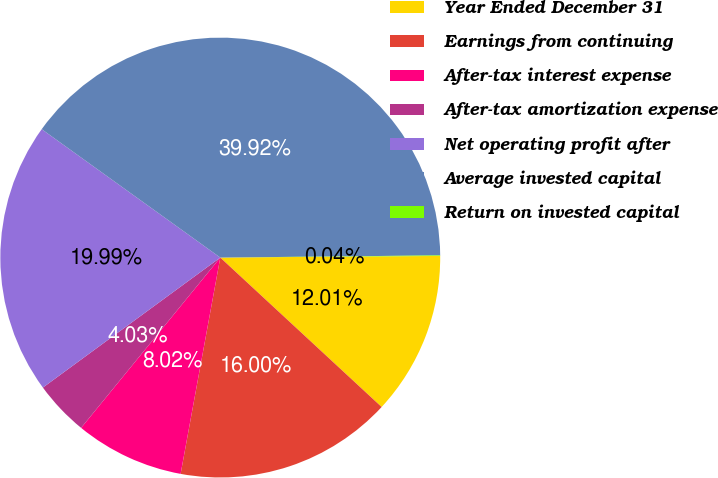Convert chart to OTSL. <chart><loc_0><loc_0><loc_500><loc_500><pie_chart><fcel>Year Ended December 31<fcel>Earnings from continuing<fcel>After-tax interest expense<fcel>After-tax amortization expense<fcel>Net operating profit after<fcel>Average invested capital<fcel>Return on invested capital<nl><fcel>12.01%<fcel>16.0%<fcel>8.02%<fcel>4.03%<fcel>19.99%<fcel>39.93%<fcel>0.04%<nl></chart> 